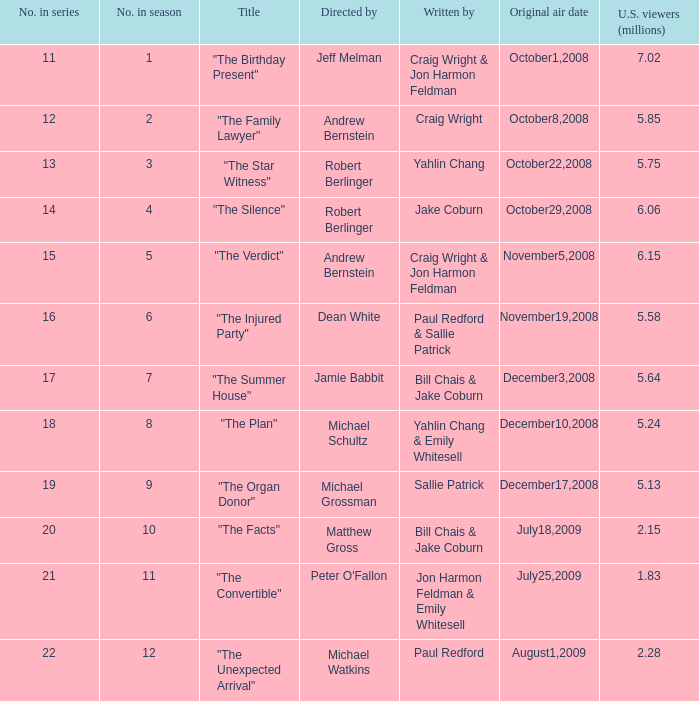For the episode "the family lawyer," what is its number in the season? 2.0. 